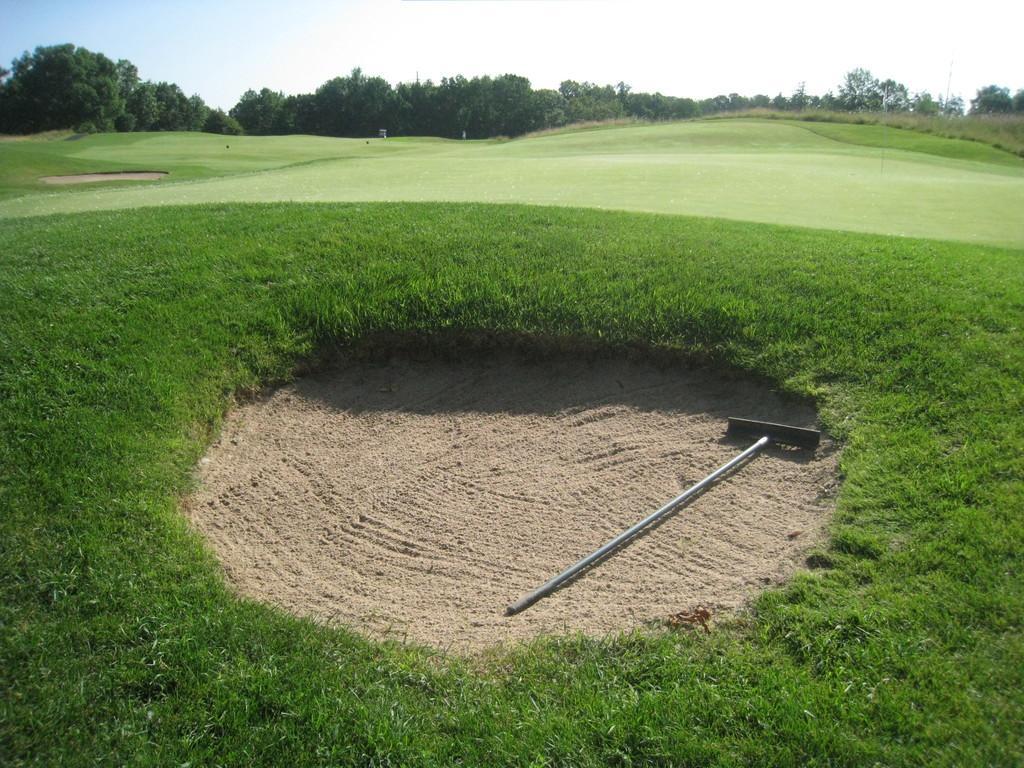Please provide a concise description of this image. In this image there is a metal rod in the sand, few trees, poles, grass and the sky. 